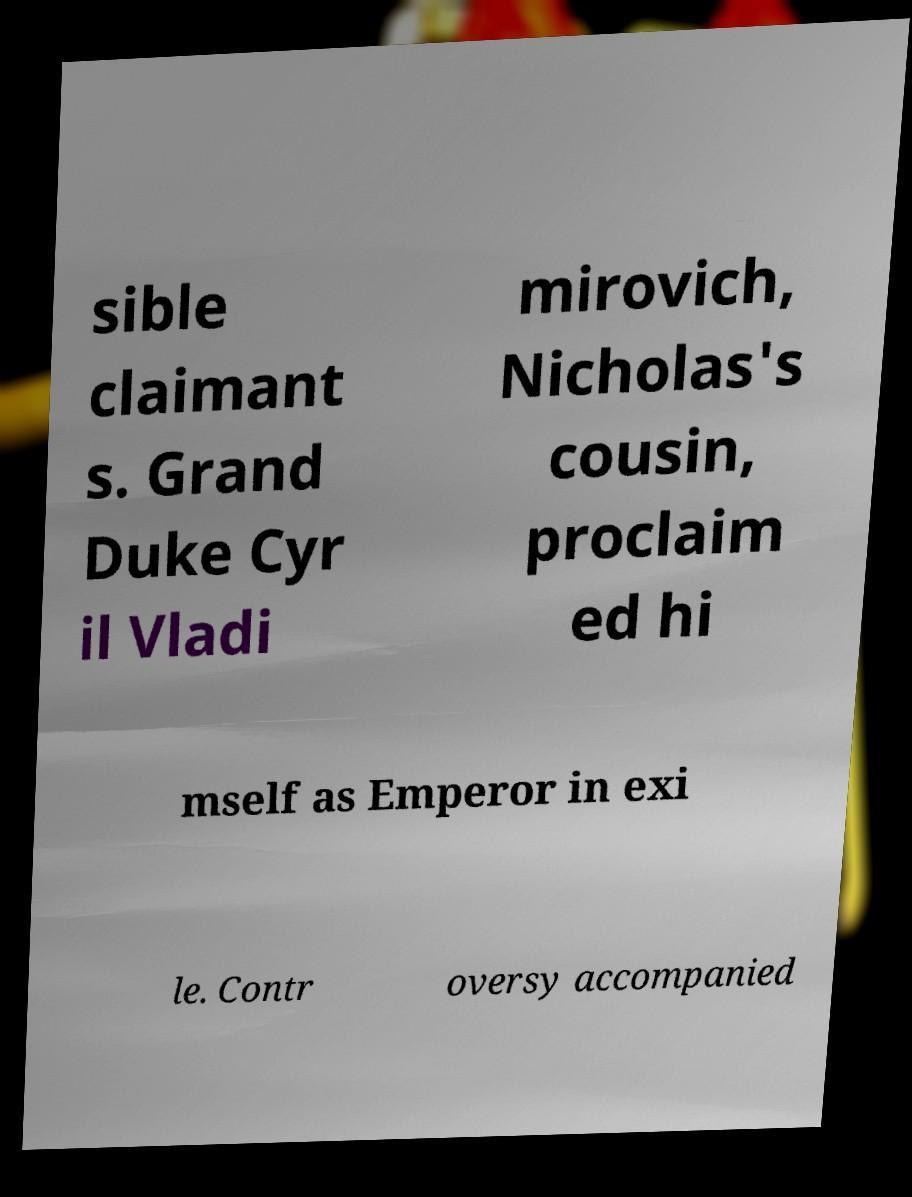Please read and relay the text visible in this image. What does it say? sible claimant s. Grand Duke Cyr il Vladi mirovich, Nicholas's cousin, proclaim ed hi mself as Emperor in exi le. Contr oversy accompanied 